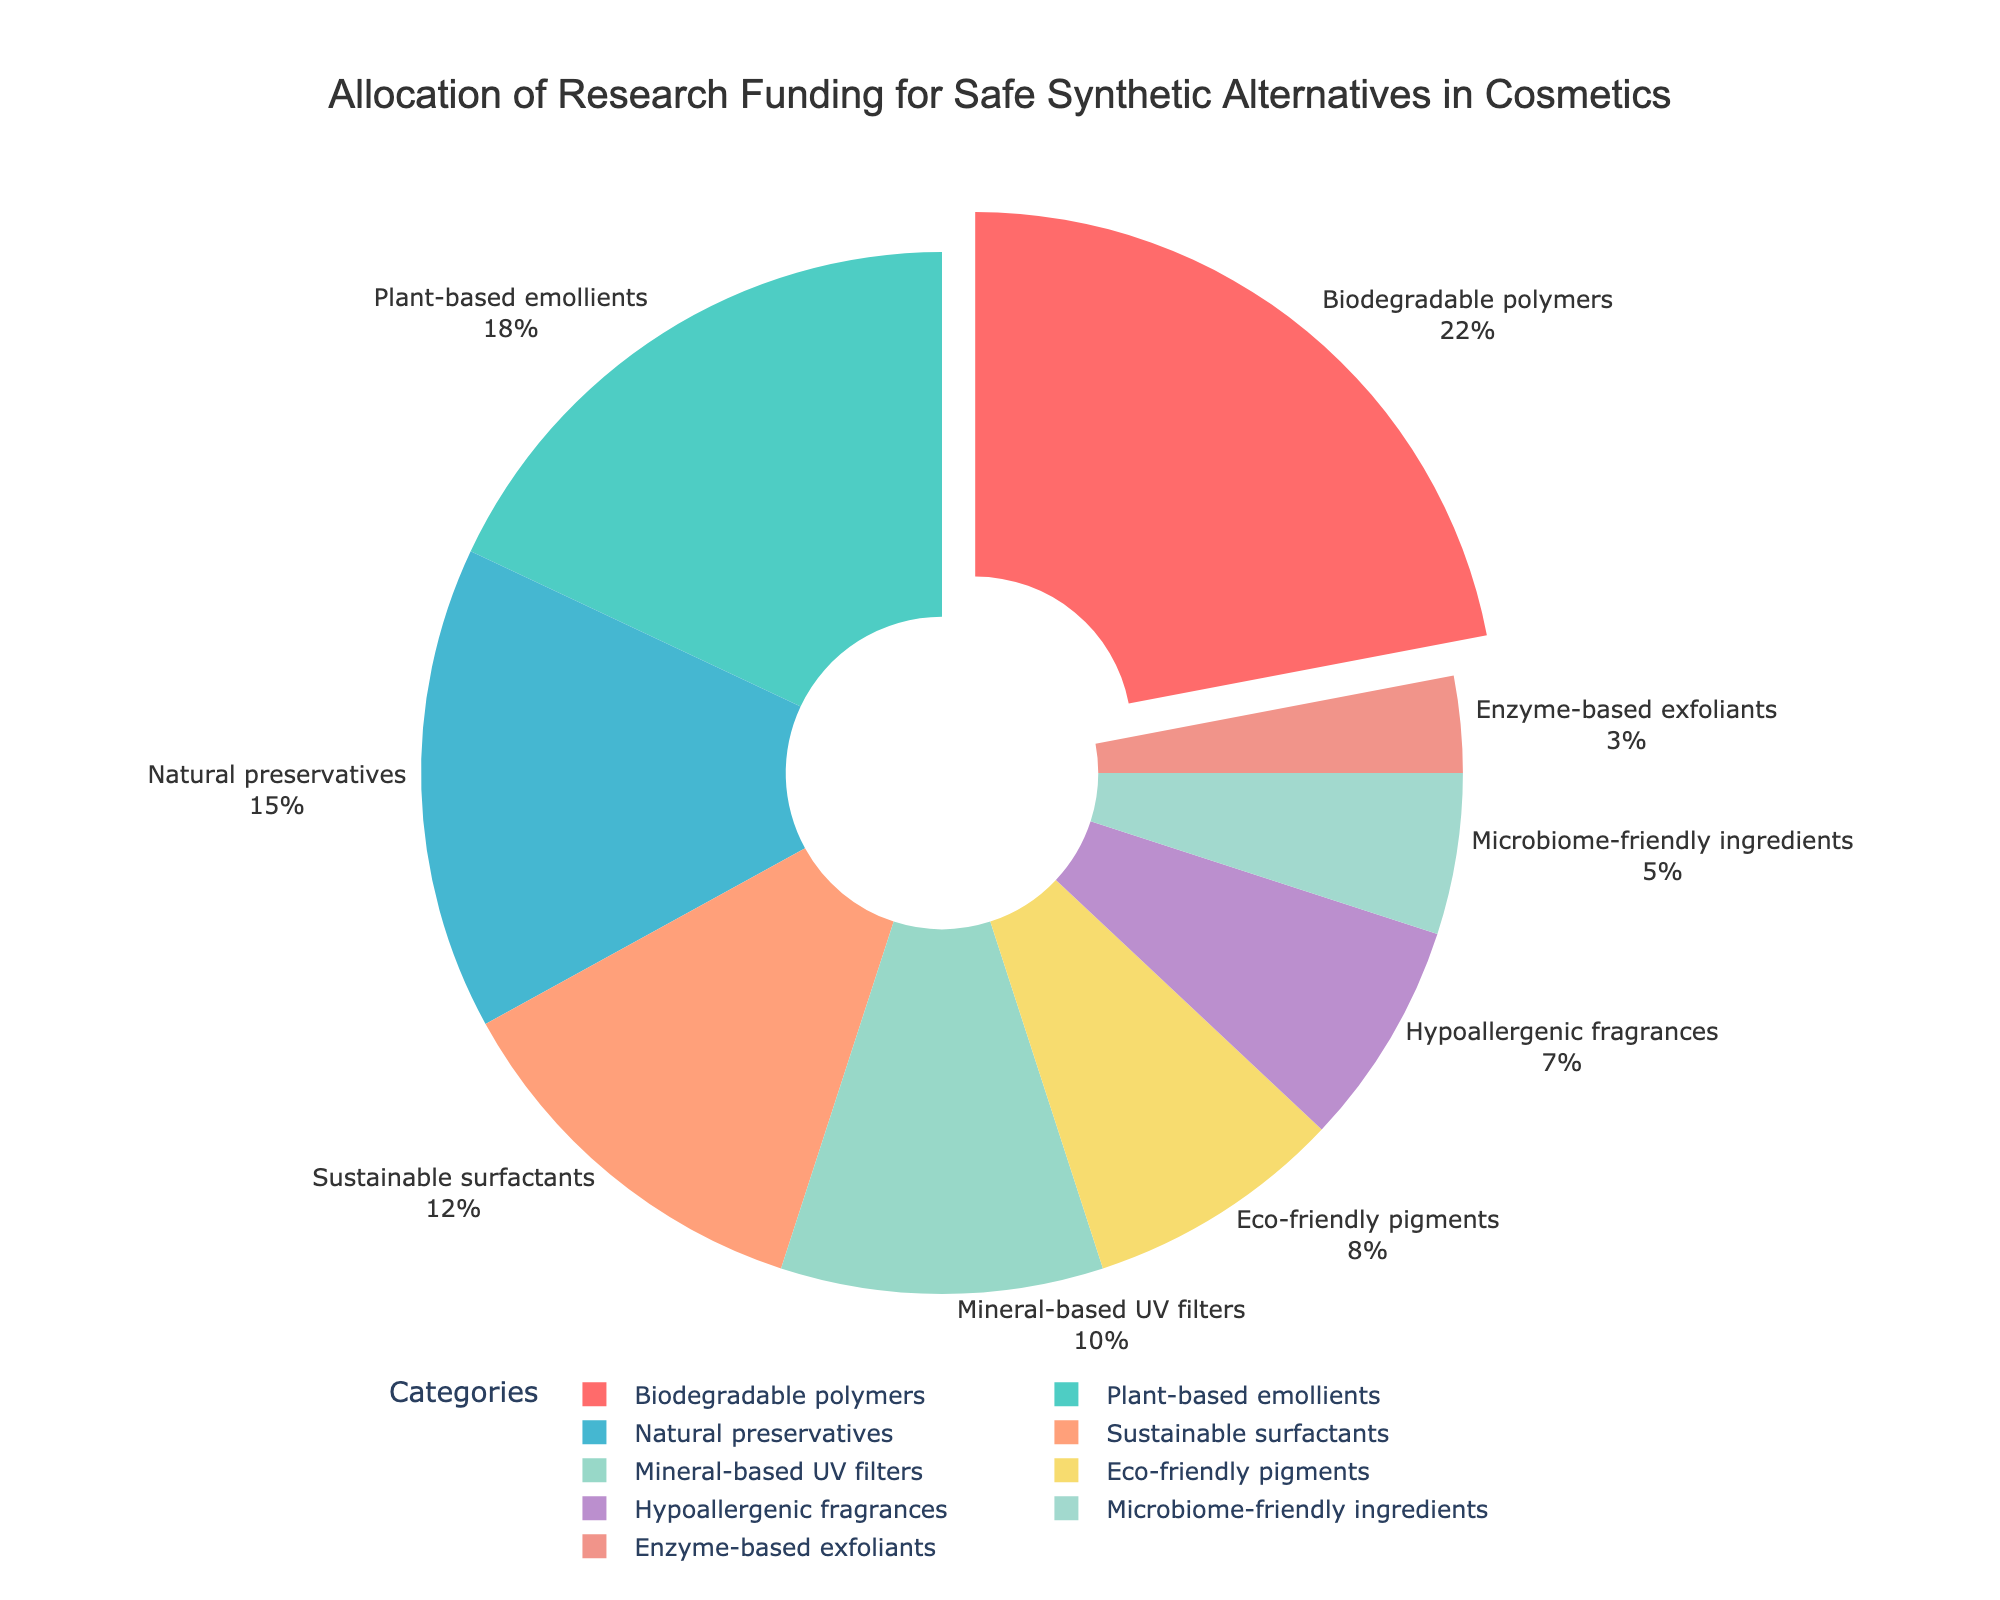1. Which category has the highest allocation of research funding? Look for the segment with the largest percentage in the pie chart. In this case, "Biodegradable polymers" has the highest allocation at 22%.
Answer: Biodegradable polymers 2. How much more funding is allocated to Biodegradable polymers compared to Plant-based emollients? Determine the difference in percentages between Biodegradable polymers (22%) and Plant-based emollients (18%). Calculation: 22% - 18% = 4%.
Answer: 4% 3. What is the combined percentage of funding allocated to Natural preservatives and Sustainable surfactants? Add the percentages of Natural preservatives (15%) and Sustainable surfactants (12%). Calculation: 15% + 12% = 27%.
Answer: 27% 4. Which category has the smallest allocation of research funding? Look for the segment with the smallest percentage in the pie chart. "Enzyme-based exfoliants" has the smallest allocation at 3%.
Answer: Enzyme-based exfoliants 5. Are there more funds allocated to Eco-friendly pigments or Hypoallergenic fragrances? Compare the percentages of Eco-friendly pigments (8%) and Hypoallergenic fragrances (7%). 8% is greater than 7%.
Answer: Eco-friendly pigments 6. What percentage of the total research funding is allocated to categories with plant-based or biodegradable components (Biodegradable polymers and Plant-based emollients)? Add the percentages of Biodegradable polymers (22%) and Plant-based emollients (18%). Calculation: 22% + 18% = 40%.
Answer: 40% 7. What color represents Sustainable surfactants in the pie chart? Identify the color used for the percentage segment of Sustainable surfactants (12%). The pie chart legend or segment color shows that Sustainable surfactants are colored orange.
Answer: Orange 8. How much more funding is given to Natural preservatives compared to Hypoallergenic fragrances and Microbiome-friendly ingredients combined? Add the percentages for Hypoallergenic fragrances (7%) and Microbiome-friendly ingredients (5%) and compare with Natural preservatives (15%). Calculation: (7% + 5%) = 12%; Then 15% - 12% = 3%.
Answer: 3% 9. What combined percentage is allocated to Mineral-based UV filters, Sustainable surfactants, and Microbiome-friendly ingredients? Sum the percentages: Mineral-based UV filters (10%), Sustainable surfactants (12%), and Microbiome-friendly ingredients (5%). Calculation: 10% + 12% + 5% = 27%.
Answer: 27% 10. Which category has the higher percentage allocation between Hypoallergenic fragrances and Enzyme-based exfoliants? Compare the percentages of Hypoallergenic fragrances (7%) and Enzyme-based exfoliants (3%). 7% is greater than 3%.
Answer: Hypoallergenic fragrances 